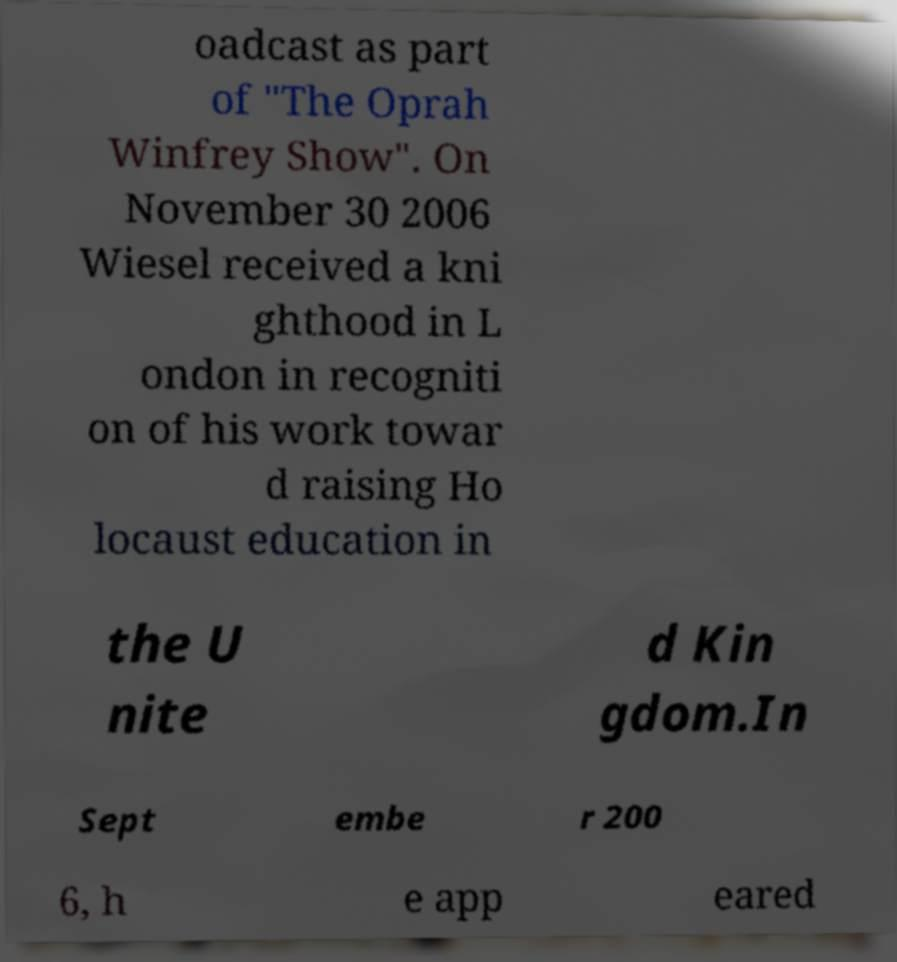Can you accurately transcribe the text from the provided image for me? oadcast as part of "The Oprah Winfrey Show". On November 30 2006 Wiesel received a kni ghthood in L ondon in recogniti on of his work towar d raising Ho locaust education in the U nite d Kin gdom.In Sept embe r 200 6, h e app eared 